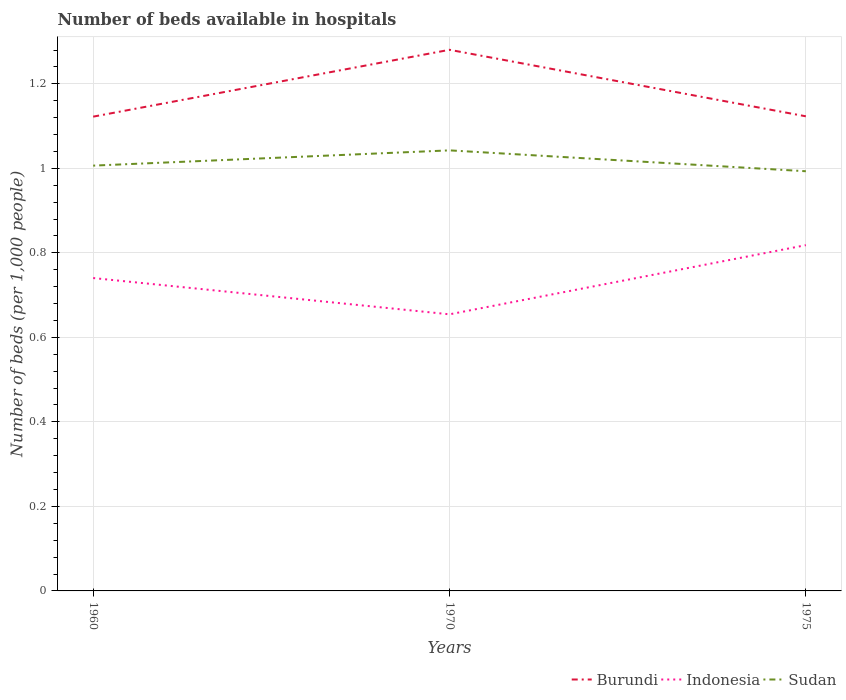How many different coloured lines are there?
Ensure brevity in your answer.  3. Does the line corresponding to Sudan intersect with the line corresponding to Burundi?
Make the answer very short. No. Across all years, what is the maximum number of beds in the hospiatls of in Burundi?
Give a very brief answer. 1.12. In which year was the number of beds in the hospiatls of in Indonesia maximum?
Make the answer very short. 1970. What is the total number of beds in the hospiatls of in Burundi in the graph?
Give a very brief answer. -0. What is the difference between the highest and the second highest number of beds in the hospiatls of in Indonesia?
Make the answer very short. 0.16. What is the difference between the highest and the lowest number of beds in the hospiatls of in Burundi?
Offer a terse response. 1. How many lines are there?
Offer a very short reply. 3. Does the graph contain grids?
Provide a succinct answer. Yes. What is the title of the graph?
Your answer should be very brief. Number of beds available in hospitals. Does "Zimbabwe" appear as one of the legend labels in the graph?
Provide a succinct answer. No. What is the label or title of the X-axis?
Keep it short and to the point. Years. What is the label or title of the Y-axis?
Keep it short and to the point. Number of beds (per 1,0 people). What is the Number of beds (per 1,000 people) in Burundi in 1960?
Your answer should be very brief. 1.12. What is the Number of beds (per 1,000 people) in Indonesia in 1960?
Your answer should be very brief. 0.74. What is the Number of beds (per 1,000 people) of Sudan in 1960?
Offer a very short reply. 1.01. What is the Number of beds (per 1,000 people) of Burundi in 1970?
Your answer should be compact. 1.28. What is the Number of beds (per 1,000 people) of Indonesia in 1970?
Make the answer very short. 0.65. What is the Number of beds (per 1,000 people) of Sudan in 1970?
Your answer should be very brief. 1.04. What is the Number of beds (per 1,000 people) in Burundi in 1975?
Your answer should be very brief. 1.12. What is the Number of beds (per 1,000 people) in Indonesia in 1975?
Offer a terse response. 0.82. What is the Number of beds (per 1,000 people) of Sudan in 1975?
Your answer should be compact. 0.99. Across all years, what is the maximum Number of beds (per 1,000 people) in Burundi?
Your response must be concise. 1.28. Across all years, what is the maximum Number of beds (per 1,000 people) of Indonesia?
Your answer should be very brief. 0.82. Across all years, what is the maximum Number of beds (per 1,000 people) of Sudan?
Keep it short and to the point. 1.04. Across all years, what is the minimum Number of beds (per 1,000 people) of Burundi?
Your answer should be compact. 1.12. Across all years, what is the minimum Number of beds (per 1,000 people) of Indonesia?
Keep it short and to the point. 0.65. Across all years, what is the minimum Number of beds (per 1,000 people) of Sudan?
Offer a very short reply. 0.99. What is the total Number of beds (per 1,000 people) of Burundi in the graph?
Offer a terse response. 3.53. What is the total Number of beds (per 1,000 people) in Indonesia in the graph?
Offer a terse response. 2.21. What is the total Number of beds (per 1,000 people) of Sudan in the graph?
Make the answer very short. 3.04. What is the difference between the Number of beds (per 1,000 people) in Burundi in 1960 and that in 1970?
Offer a terse response. -0.16. What is the difference between the Number of beds (per 1,000 people) in Indonesia in 1960 and that in 1970?
Offer a very short reply. 0.09. What is the difference between the Number of beds (per 1,000 people) in Sudan in 1960 and that in 1970?
Provide a succinct answer. -0.04. What is the difference between the Number of beds (per 1,000 people) in Burundi in 1960 and that in 1975?
Provide a succinct answer. -0. What is the difference between the Number of beds (per 1,000 people) of Indonesia in 1960 and that in 1975?
Your response must be concise. -0.08. What is the difference between the Number of beds (per 1,000 people) in Sudan in 1960 and that in 1975?
Provide a succinct answer. 0.01. What is the difference between the Number of beds (per 1,000 people) of Burundi in 1970 and that in 1975?
Ensure brevity in your answer.  0.16. What is the difference between the Number of beds (per 1,000 people) of Indonesia in 1970 and that in 1975?
Ensure brevity in your answer.  -0.16. What is the difference between the Number of beds (per 1,000 people) of Sudan in 1970 and that in 1975?
Give a very brief answer. 0.05. What is the difference between the Number of beds (per 1,000 people) of Burundi in 1960 and the Number of beds (per 1,000 people) of Indonesia in 1970?
Your answer should be very brief. 0.47. What is the difference between the Number of beds (per 1,000 people) in Burundi in 1960 and the Number of beds (per 1,000 people) in Sudan in 1970?
Make the answer very short. 0.08. What is the difference between the Number of beds (per 1,000 people) in Indonesia in 1960 and the Number of beds (per 1,000 people) in Sudan in 1970?
Ensure brevity in your answer.  -0.3. What is the difference between the Number of beds (per 1,000 people) of Burundi in 1960 and the Number of beds (per 1,000 people) of Indonesia in 1975?
Provide a succinct answer. 0.3. What is the difference between the Number of beds (per 1,000 people) of Burundi in 1960 and the Number of beds (per 1,000 people) of Sudan in 1975?
Give a very brief answer. 0.13. What is the difference between the Number of beds (per 1,000 people) in Indonesia in 1960 and the Number of beds (per 1,000 people) in Sudan in 1975?
Ensure brevity in your answer.  -0.25. What is the difference between the Number of beds (per 1,000 people) of Burundi in 1970 and the Number of beds (per 1,000 people) of Indonesia in 1975?
Provide a succinct answer. 0.46. What is the difference between the Number of beds (per 1,000 people) of Burundi in 1970 and the Number of beds (per 1,000 people) of Sudan in 1975?
Ensure brevity in your answer.  0.29. What is the difference between the Number of beds (per 1,000 people) of Indonesia in 1970 and the Number of beds (per 1,000 people) of Sudan in 1975?
Provide a short and direct response. -0.34. What is the average Number of beds (per 1,000 people) of Burundi per year?
Make the answer very short. 1.18. What is the average Number of beds (per 1,000 people) of Indonesia per year?
Ensure brevity in your answer.  0.74. What is the average Number of beds (per 1,000 people) of Sudan per year?
Give a very brief answer. 1.01. In the year 1960, what is the difference between the Number of beds (per 1,000 people) in Burundi and Number of beds (per 1,000 people) in Indonesia?
Offer a terse response. 0.38. In the year 1960, what is the difference between the Number of beds (per 1,000 people) in Burundi and Number of beds (per 1,000 people) in Sudan?
Your answer should be very brief. 0.12. In the year 1960, what is the difference between the Number of beds (per 1,000 people) of Indonesia and Number of beds (per 1,000 people) of Sudan?
Provide a short and direct response. -0.27. In the year 1970, what is the difference between the Number of beds (per 1,000 people) of Burundi and Number of beds (per 1,000 people) of Indonesia?
Your answer should be compact. 0.63. In the year 1970, what is the difference between the Number of beds (per 1,000 people) of Burundi and Number of beds (per 1,000 people) of Sudan?
Your answer should be compact. 0.24. In the year 1970, what is the difference between the Number of beds (per 1,000 people) of Indonesia and Number of beds (per 1,000 people) of Sudan?
Give a very brief answer. -0.39. In the year 1975, what is the difference between the Number of beds (per 1,000 people) of Burundi and Number of beds (per 1,000 people) of Indonesia?
Give a very brief answer. 0.3. In the year 1975, what is the difference between the Number of beds (per 1,000 people) of Burundi and Number of beds (per 1,000 people) of Sudan?
Offer a very short reply. 0.13. In the year 1975, what is the difference between the Number of beds (per 1,000 people) of Indonesia and Number of beds (per 1,000 people) of Sudan?
Offer a terse response. -0.17. What is the ratio of the Number of beds (per 1,000 people) of Burundi in 1960 to that in 1970?
Give a very brief answer. 0.88. What is the ratio of the Number of beds (per 1,000 people) in Indonesia in 1960 to that in 1970?
Offer a very short reply. 1.13. What is the ratio of the Number of beds (per 1,000 people) of Sudan in 1960 to that in 1970?
Your answer should be very brief. 0.97. What is the ratio of the Number of beds (per 1,000 people) in Burundi in 1960 to that in 1975?
Keep it short and to the point. 1. What is the ratio of the Number of beds (per 1,000 people) of Indonesia in 1960 to that in 1975?
Ensure brevity in your answer.  0.9. What is the ratio of the Number of beds (per 1,000 people) in Sudan in 1960 to that in 1975?
Give a very brief answer. 1.01. What is the ratio of the Number of beds (per 1,000 people) in Burundi in 1970 to that in 1975?
Your response must be concise. 1.14. What is the ratio of the Number of beds (per 1,000 people) of Sudan in 1970 to that in 1975?
Your answer should be very brief. 1.05. What is the difference between the highest and the second highest Number of beds (per 1,000 people) in Burundi?
Your answer should be compact. 0.16. What is the difference between the highest and the second highest Number of beds (per 1,000 people) of Indonesia?
Offer a very short reply. 0.08. What is the difference between the highest and the second highest Number of beds (per 1,000 people) of Sudan?
Your answer should be compact. 0.04. What is the difference between the highest and the lowest Number of beds (per 1,000 people) of Burundi?
Your answer should be very brief. 0.16. What is the difference between the highest and the lowest Number of beds (per 1,000 people) in Indonesia?
Your answer should be compact. 0.16. What is the difference between the highest and the lowest Number of beds (per 1,000 people) of Sudan?
Offer a very short reply. 0.05. 